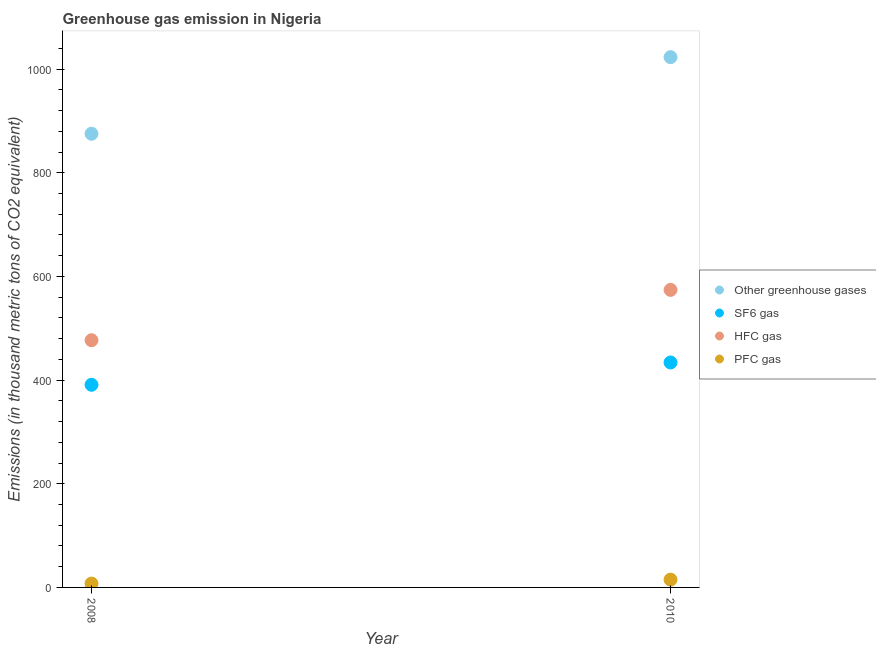What is the emission of greenhouse gases in 2008?
Provide a succinct answer. 875.2. Across all years, what is the maximum emission of greenhouse gases?
Keep it short and to the point. 1023. Across all years, what is the minimum emission of sf6 gas?
Keep it short and to the point. 390.9. In which year was the emission of sf6 gas minimum?
Provide a succinct answer. 2008. What is the total emission of greenhouse gases in the graph?
Keep it short and to the point. 1898.2. What is the difference between the emission of hfc gas in 2008 and that in 2010?
Provide a succinct answer. -97.1. What is the difference between the emission of pfc gas in 2010 and the emission of greenhouse gases in 2008?
Keep it short and to the point. -860.2. What is the average emission of pfc gas per year?
Provide a succinct answer. 11.2. In the year 2010, what is the difference between the emission of sf6 gas and emission of pfc gas?
Provide a short and direct response. 419. What is the ratio of the emission of sf6 gas in 2008 to that in 2010?
Provide a succinct answer. 0.9. In how many years, is the emission of sf6 gas greater than the average emission of sf6 gas taken over all years?
Offer a terse response. 1. Does the emission of hfc gas monotonically increase over the years?
Make the answer very short. Yes. Is the emission of sf6 gas strictly less than the emission of pfc gas over the years?
Offer a terse response. No. What is the difference between two consecutive major ticks on the Y-axis?
Offer a terse response. 200. Are the values on the major ticks of Y-axis written in scientific E-notation?
Make the answer very short. No. Does the graph contain any zero values?
Your response must be concise. No. Does the graph contain grids?
Offer a terse response. No. Where does the legend appear in the graph?
Offer a very short reply. Center right. How many legend labels are there?
Your answer should be compact. 4. What is the title of the graph?
Offer a terse response. Greenhouse gas emission in Nigeria. What is the label or title of the X-axis?
Your response must be concise. Year. What is the label or title of the Y-axis?
Offer a very short reply. Emissions (in thousand metric tons of CO2 equivalent). What is the Emissions (in thousand metric tons of CO2 equivalent) of Other greenhouse gases in 2008?
Your response must be concise. 875.2. What is the Emissions (in thousand metric tons of CO2 equivalent) of SF6 gas in 2008?
Provide a short and direct response. 390.9. What is the Emissions (in thousand metric tons of CO2 equivalent) of HFC gas in 2008?
Your answer should be compact. 476.9. What is the Emissions (in thousand metric tons of CO2 equivalent) in PFC gas in 2008?
Offer a terse response. 7.4. What is the Emissions (in thousand metric tons of CO2 equivalent) of Other greenhouse gases in 2010?
Your answer should be very brief. 1023. What is the Emissions (in thousand metric tons of CO2 equivalent) of SF6 gas in 2010?
Your response must be concise. 434. What is the Emissions (in thousand metric tons of CO2 equivalent) in HFC gas in 2010?
Your answer should be very brief. 574. Across all years, what is the maximum Emissions (in thousand metric tons of CO2 equivalent) of Other greenhouse gases?
Your answer should be very brief. 1023. Across all years, what is the maximum Emissions (in thousand metric tons of CO2 equivalent) of SF6 gas?
Offer a very short reply. 434. Across all years, what is the maximum Emissions (in thousand metric tons of CO2 equivalent) of HFC gas?
Ensure brevity in your answer.  574. Across all years, what is the minimum Emissions (in thousand metric tons of CO2 equivalent) in Other greenhouse gases?
Provide a short and direct response. 875.2. Across all years, what is the minimum Emissions (in thousand metric tons of CO2 equivalent) of SF6 gas?
Give a very brief answer. 390.9. Across all years, what is the minimum Emissions (in thousand metric tons of CO2 equivalent) of HFC gas?
Ensure brevity in your answer.  476.9. What is the total Emissions (in thousand metric tons of CO2 equivalent) of Other greenhouse gases in the graph?
Give a very brief answer. 1898.2. What is the total Emissions (in thousand metric tons of CO2 equivalent) of SF6 gas in the graph?
Make the answer very short. 824.9. What is the total Emissions (in thousand metric tons of CO2 equivalent) of HFC gas in the graph?
Provide a succinct answer. 1050.9. What is the total Emissions (in thousand metric tons of CO2 equivalent) of PFC gas in the graph?
Give a very brief answer. 22.4. What is the difference between the Emissions (in thousand metric tons of CO2 equivalent) in Other greenhouse gases in 2008 and that in 2010?
Make the answer very short. -147.8. What is the difference between the Emissions (in thousand metric tons of CO2 equivalent) in SF6 gas in 2008 and that in 2010?
Offer a terse response. -43.1. What is the difference between the Emissions (in thousand metric tons of CO2 equivalent) of HFC gas in 2008 and that in 2010?
Ensure brevity in your answer.  -97.1. What is the difference between the Emissions (in thousand metric tons of CO2 equivalent) of Other greenhouse gases in 2008 and the Emissions (in thousand metric tons of CO2 equivalent) of SF6 gas in 2010?
Your response must be concise. 441.2. What is the difference between the Emissions (in thousand metric tons of CO2 equivalent) of Other greenhouse gases in 2008 and the Emissions (in thousand metric tons of CO2 equivalent) of HFC gas in 2010?
Provide a succinct answer. 301.2. What is the difference between the Emissions (in thousand metric tons of CO2 equivalent) of Other greenhouse gases in 2008 and the Emissions (in thousand metric tons of CO2 equivalent) of PFC gas in 2010?
Offer a very short reply. 860.2. What is the difference between the Emissions (in thousand metric tons of CO2 equivalent) in SF6 gas in 2008 and the Emissions (in thousand metric tons of CO2 equivalent) in HFC gas in 2010?
Your answer should be compact. -183.1. What is the difference between the Emissions (in thousand metric tons of CO2 equivalent) in SF6 gas in 2008 and the Emissions (in thousand metric tons of CO2 equivalent) in PFC gas in 2010?
Keep it short and to the point. 375.9. What is the difference between the Emissions (in thousand metric tons of CO2 equivalent) of HFC gas in 2008 and the Emissions (in thousand metric tons of CO2 equivalent) of PFC gas in 2010?
Provide a short and direct response. 461.9. What is the average Emissions (in thousand metric tons of CO2 equivalent) in Other greenhouse gases per year?
Ensure brevity in your answer.  949.1. What is the average Emissions (in thousand metric tons of CO2 equivalent) in SF6 gas per year?
Give a very brief answer. 412.45. What is the average Emissions (in thousand metric tons of CO2 equivalent) of HFC gas per year?
Your answer should be compact. 525.45. In the year 2008, what is the difference between the Emissions (in thousand metric tons of CO2 equivalent) in Other greenhouse gases and Emissions (in thousand metric tons of CO2 equivalent) in SF6 gas?
Keep it short and to the point. 484.3. In the year 2008, what is the difference between the Emissions (in thousand metric tons of CO2 equivalent) of Other greenhouse gases and Emissions (in thousand metric tons of CO2 equivalent) of HFC gas?
Give a very brief answer. 398.3. In the year 2008, what is the difference between the Emissions (in thousand metric tons of CO2 equivalent) in Other greenhouse gases and Emissions (in thousand metric tons of CO2 equivalent) in PFC gas?
Provide a short and direct response. 867.8. In the year 2008, what is the difference between the Emissions (in thousand metric tons of CO2 equivalent) of SF6 gas and Emissions (in thousand metric tons of CO2 equivalent) of HFC gas?
Ensure brevity in your answer.  -86. In the year 2008, what is the difference between the Emissions (in thousand metric tons of CO2 equivalent) of SF6 gas and Emissions (in thousand metric tons of CO2 equivalent) of PFC gas?
Your answer should be very brief. 383.5. In the year 2008, what is the difference between the Emissions (in thousand metric tons of CO2 equivalent) in HFC gas and Emissions (in thousand metric tons of CO2 equivalent) in PFC gas?
Provide a short and direct response. 469.5. In the year 2010, what is the difference between the Emissions (in thousand metric tons of CO2 equivalent) in Other greenhouse gases and Emissions (in thousand metric tons of CO2 equivalent) in SF6 gas?
Ensure brevity in your answer.  589. In the year 2010, what is the difference between the Emissions (in thousand metric tons of CO2 equivalent) in Other greenhouse gases and Emissions (in thousand metric tons of CO2 equivalent) in HFC gas?
Make the answer very short. 449. In the year 2010, what is the difference between the Emissions (in thousand metric tons of CO2 equivalent) in Other greenhouse gases and Emissions (in thousand metric tons of CO2 equivalent) in PFC gas?
Give a very brief answer. 1008. In the year 2010, what is the difference between the Emissions (in thousand metric tons of CO2 equivalent) of SF6 gas and Emissions (in thousand metric tons of CO2 equivalent) of HFC gas?
Make the answer very short. -140. In the year 2010, what is the difference between the Emissions (in thousand metric tons of CO2 equivalent) of SF6 gas and Emissions (in thousand metric tons of CO2 equivalent) of PFC gas?
Provide a short and direct response. 419. In the year 2010, what is the difference between the Emissions (in thousand metric tons of CO2 equivalent) of HFC gas and Emissions (in thousand metric tons of CO2 equivalent) of PFC gas?
Offer a terse response. 559. What is the ratio of the Emissions (in thousand metric tons of CO2 equivalent) in Other greenhouse gases in 2008 to that in 2010?
Make the answer very short. 0.86. What is the ratio of the Emissions (in thousand metric tons of CO2 equivalent) of SF6 gas in 2008 to that in 2010?
Your response must be concise. 0.9. What is the ratio of the Emissions (in thousand metric tons of CO2 equivalent) in HFC gas in 2008 to that in 2010?
Your response must be concise. 0.83. What is the ratio of the Emissions (in thousand metric tons of CO2 equivalent) of PFC gas in 2008 to that in 2010?
Provide a succinct answer. 0.49. What is the difference between the highest and the second highest Emissions (in thousand metric tons of CO2 equivalent) in Other greenhouse gases?
Offer a terse response. 147.8. What is the difference between the highest and the second highest Emissions (in thousand metric tons of CO2 equivalent) in SF6 gas?
Provide a short and direct response. 43.1. What is the difference between the highest and the second highest Emissions (in thousand metric tons of CO2 equivalent) of HFC gas?
Your response must be concise. 97.1. What is the difference between the highest and the second highest Emissions (in thousand metric tons of CO2 equivalent) in PFC gas?
Offer a very short reply. 7.6. What is the difference between the highest and the lowest Emissions (in thousand metric tons of CO2 equivalent) of Other greenhouse gases?
Your answer should be compact. 147.8. What is the difference between the highest and the lowest Emissions (in thousand metric tons of CO2 equivalent) of SF6 gas?
Your answer should be very brief. 43.1. What is the difference between the highest and the lowest Emissions (in thousand metric tons of CO2 equivalent) of HFC gas?
Your response must be concise. 97.1. 